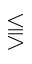Convert formula to latex. <formula><loc_0><loc_0><loc_500><loc_500>\leq s s e q q g t r</formula> 